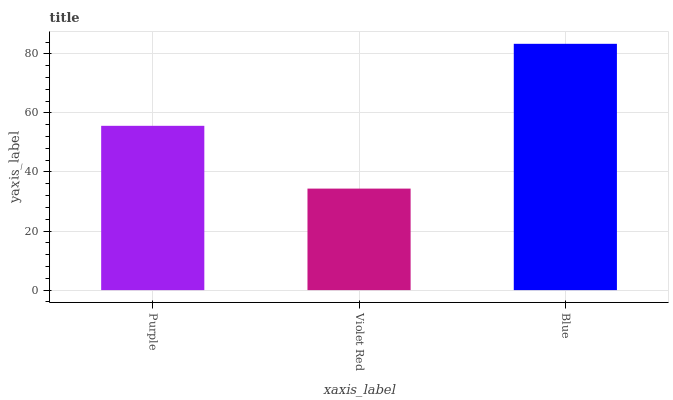Is Violet Red the minimum?
Answer yes or no. Yes. Is Blue the maximum?
Answer yes or no. Yes. Is Blue the minimum?
Answer yes or no. No. Is Violet Red the maximum?
Answer yes or no. No. Is Blue greater than Violet Red?
Answer yes or no. Yes. Is Violet Red less than Blue?
Answer yes or no. Yes. Is Violet Red greater than Blue?
Answer yes or no. No. Is Blue less than Violet Red?
Answer yes or no. No. Is Purple the high median?
Answer yes or no. Yes. Is Purple the low median?
Answer yes or no. Yes. Is Violet Red the high median?
Answer yes or no. No. Is Violet Red the low median?
Answer yes or no. No. 